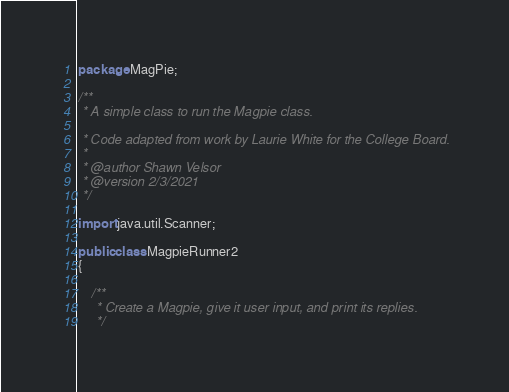<code> <loc_0><loc_0><loc_500><loc_500><_Java_>package MagPie;

/**
 * A simple class to run the Magpie class.

 * Code adapted from work by Laurie White for the College Board.
 *
 * @author Shawn Velsor
 * @version 2/3/2021
 */

import java.util.Scanner;

public class MagpieRunner2
{

    /**
     * Create a Magpie, give it user input, and print its replies.
     */</code> 